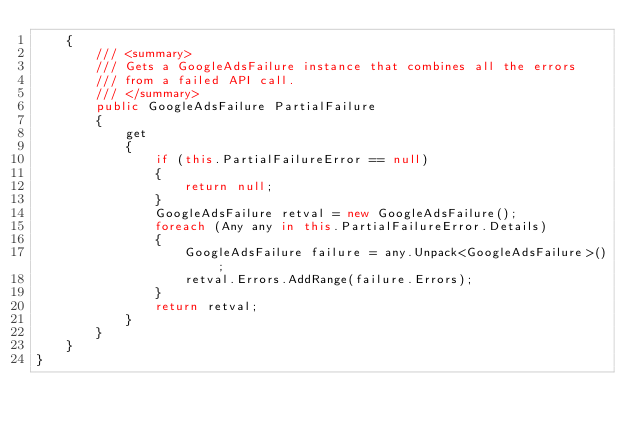<code> <loc_0><loc_0><loc_500><loc_500><_C#_>    {
        /// <summary>
        /// Gets a GoogleAdsFailure instance that combines all the errors
        /// from a failed API call.
        /// </summary>
        public GoogleAdsFailure PartialFailure
        {
            get
            {
                if (this.PartialFailureError == null)
                {
                    return null;
                }
                GoogleAdsFailure retval = new GoogleAdsFailure();
                foreach (Any any in this.PartialFailureError.Details)
                {
                    GoogleAdsFailure failure = any.Unpack<GoogleAdsFailure>();
                    retval.Errors.AddRange(failure.Errors);
                }
                return retval;
            }
        }
    }
}
</code> 